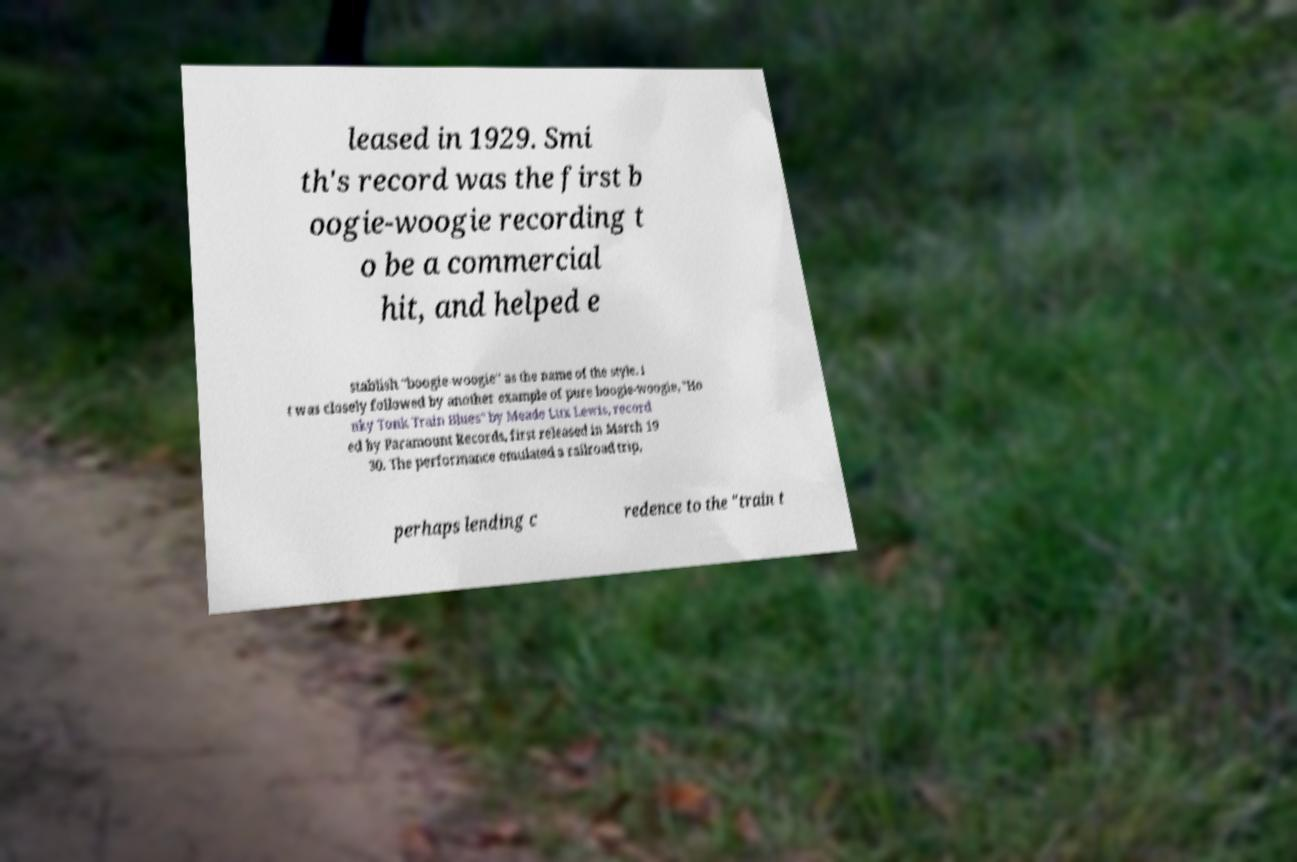Could you extract and type out the text from this image? leased in 1929. Smi th's record was the first b oogie-woogie recording t o be a commercial hit, and helped e stablish "boogie-woogie" as the name of the style. I t was closely followed by another example of pure boogie-woogie, "Ho nky Tonk Train Blues" by Meade Lux Lewis, record ed by Paramount Records, first released in March 19 30. The performance emulated a railroad trip, perhaps lending c redence to the "train t 